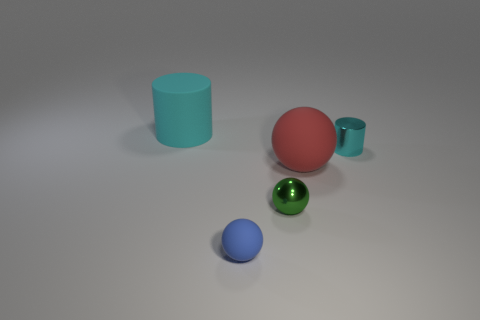Add 3 big blue metallic cylinders. How many objects exist? 8 Subtract all cylinders. How many objects are left? 3 Add 2 big spheres. How many big spheres exist? 3 Subtract 0 blue cubes. How many objects are left? 5 Subtract all cyan matte objects. Subtract all small cyan cylinders. How many objects are left? 3 Add 3 tiny balls. How many tiny balls are left? 5 